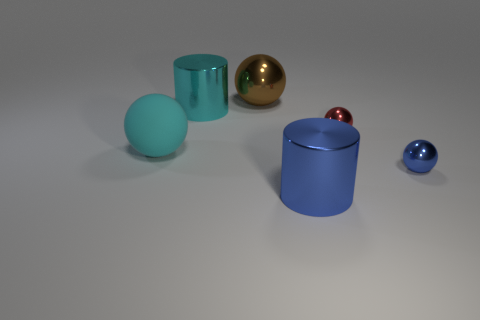Subtract all metal balls. How many balls are left? 1 Subtract all red spheres. How many spheres are left? 3 Add 2 big blue things. How many objects exist? 8 Subtract all gray spheres. Subtract all green blocks. How many spheres are left? 4 Subtract all spheres. How many objects are left? 2 Add 3 red metal objects. How many red metal objects are left? 4 Add 5 small metallic spheres. How many small metallic spheres exist? 7 Subtract 0 brown cylinders. How many objects are left? 6 Subtract all brown cylinders. Subtract all big cyan metallic cylinders. How many objects are left? 5 